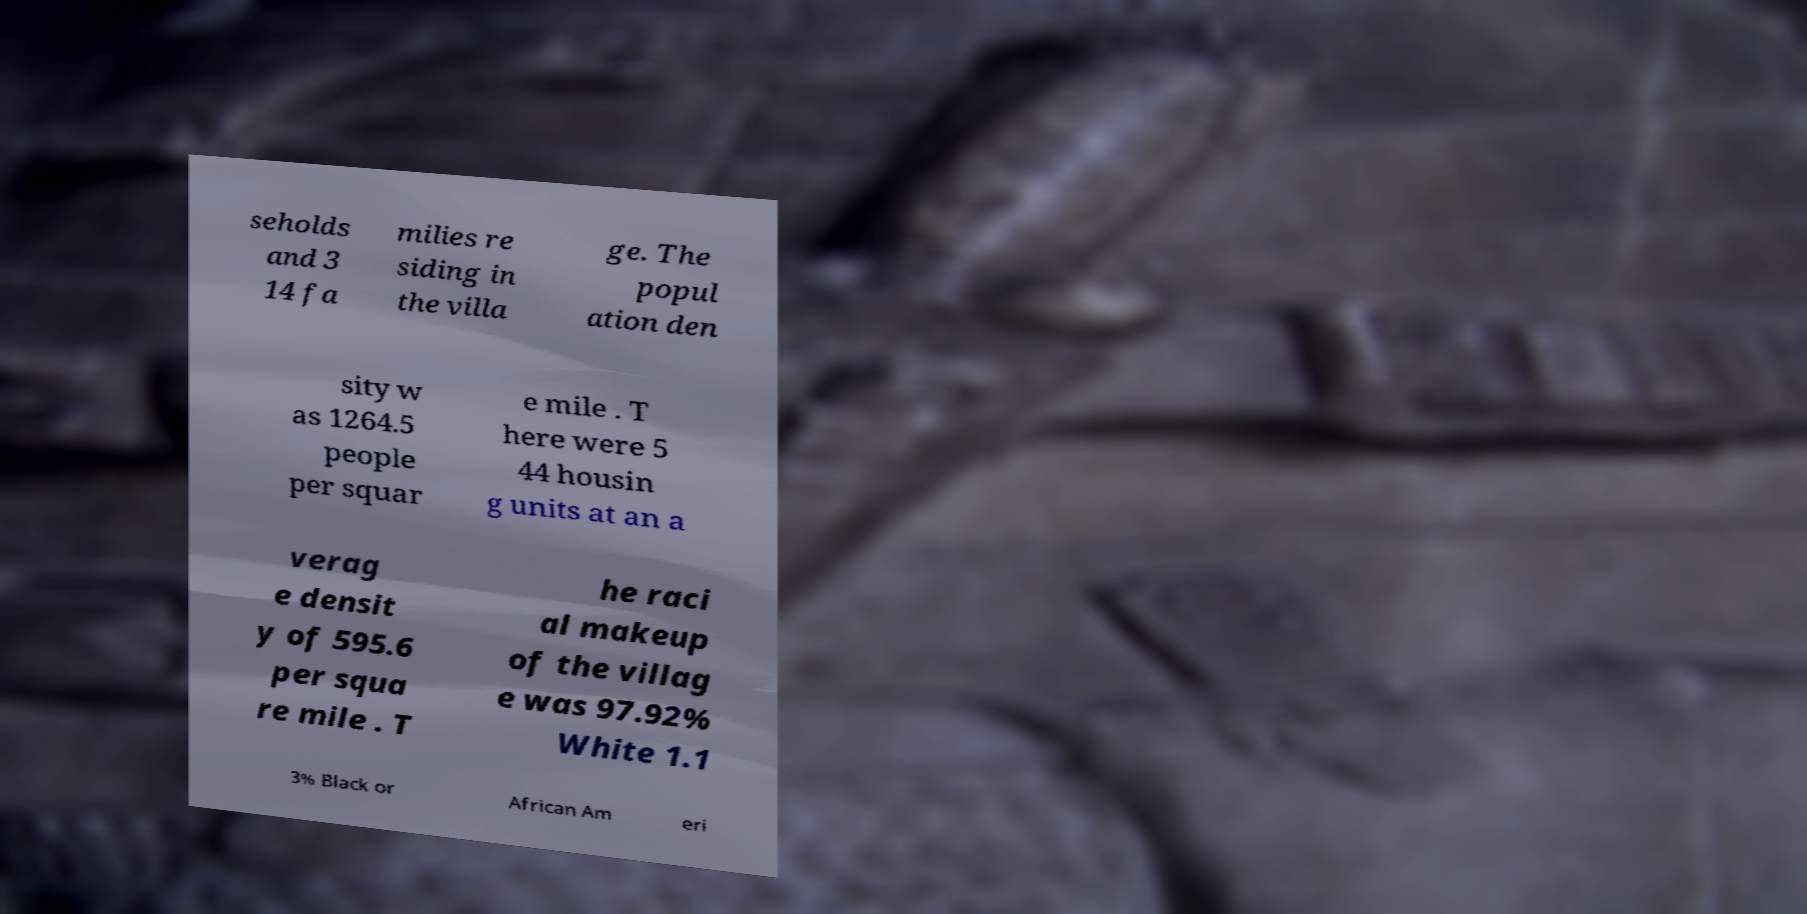For documentation purposes, I need the text within this image transcribed. Could you provide that? seholds and 3 14 fa milies re siding in the villa ge. The popul ation den sity w as 1264.5 people per squar e mile . T here were 5 44 housin g units at an a verag e densit y of 595.6 per squa re mile . T he raci al makeup of the villag e was 97.92% White 1.1 3% Black or African Am eri 